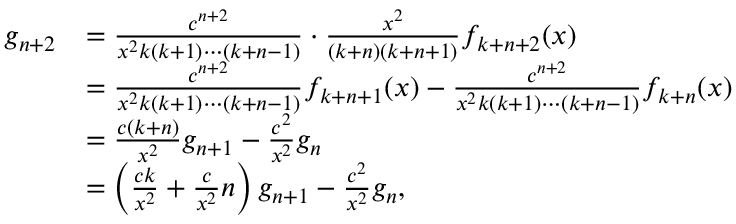<formula> <loc_0><loc_0><loc_500><loc_500>{ \begin{array} { r l } { g _ { n + 2 } } & { = { \frac { c ^ { n + 2 } } { x ^ { 2 } k ( k + 1 ) \cdots ( k + n - 1 ) } } \cdot { \frac { x ^ { 2 } } { ( k + n ) ( k + n + 1 ) } } f _ { k + n + 2 } ( x ) } \\ & { = { \frac { c ^ { n + 2 } } { x ^ { 2 } k ( k + 1 ) \cdots ( k + n - 1 ) } } f _ { k + n + 1 } ( x ) - { \frac { c ^ { n + 2 } } { x ^ { 2 } k ( k + 1 ) \cdots ( k + n - 1 ) } } f _ { k + n } ( x ) } \\ & { = { \frac { c ( k + n ) } { x ^ { 2 } } } g _ { n + 1 } - { \frac { c ^ { 2 } } { x ^ { 2 } } } g _ { n } } \\ & { = \left ( { \frac { c k } { x ^ { 2 } } } + { \frac { c } { x ^ { 2 } } } n \right ) g _ { n + 1 } - { \frac { c ^ { 2 } } { x ^ { 2 } } } g _ { n } , } \end{array} }</formula> 